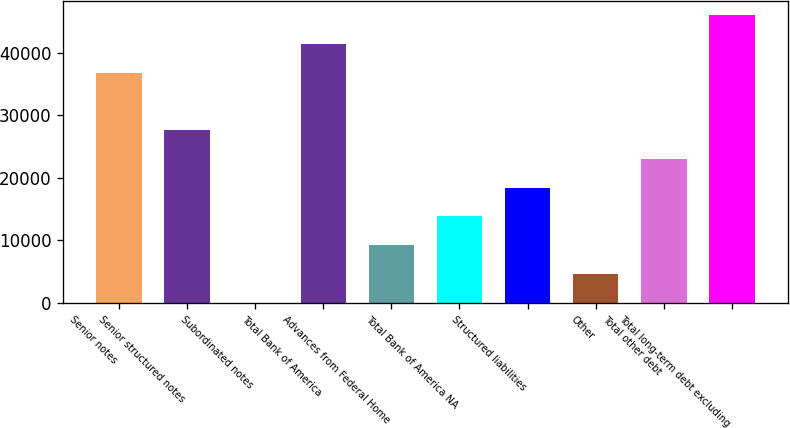Convert chart. <chart><loc_0><loc_0><loc_500><loc_500><bar_chart><fcel>Senior notes<fcel>Senior structured notes<fcel>Subordinated notes<fcel>Total Bank of America<fcel>Advances from Federal Home<fcel>Total Bank of America NA<fcel>Structured liabilities<fcel>Other<fcel>Total other debt<fcel>Total long-term debt excluding<nl><fcel>36861.6<fcel>27647.2<fcel>4<fcel>41468.8<fcel>9218.4<fcel>13825.6<fcel>18432.8<fcel>4611.2<fcel>23040<fcel>46076<nl></chart> 